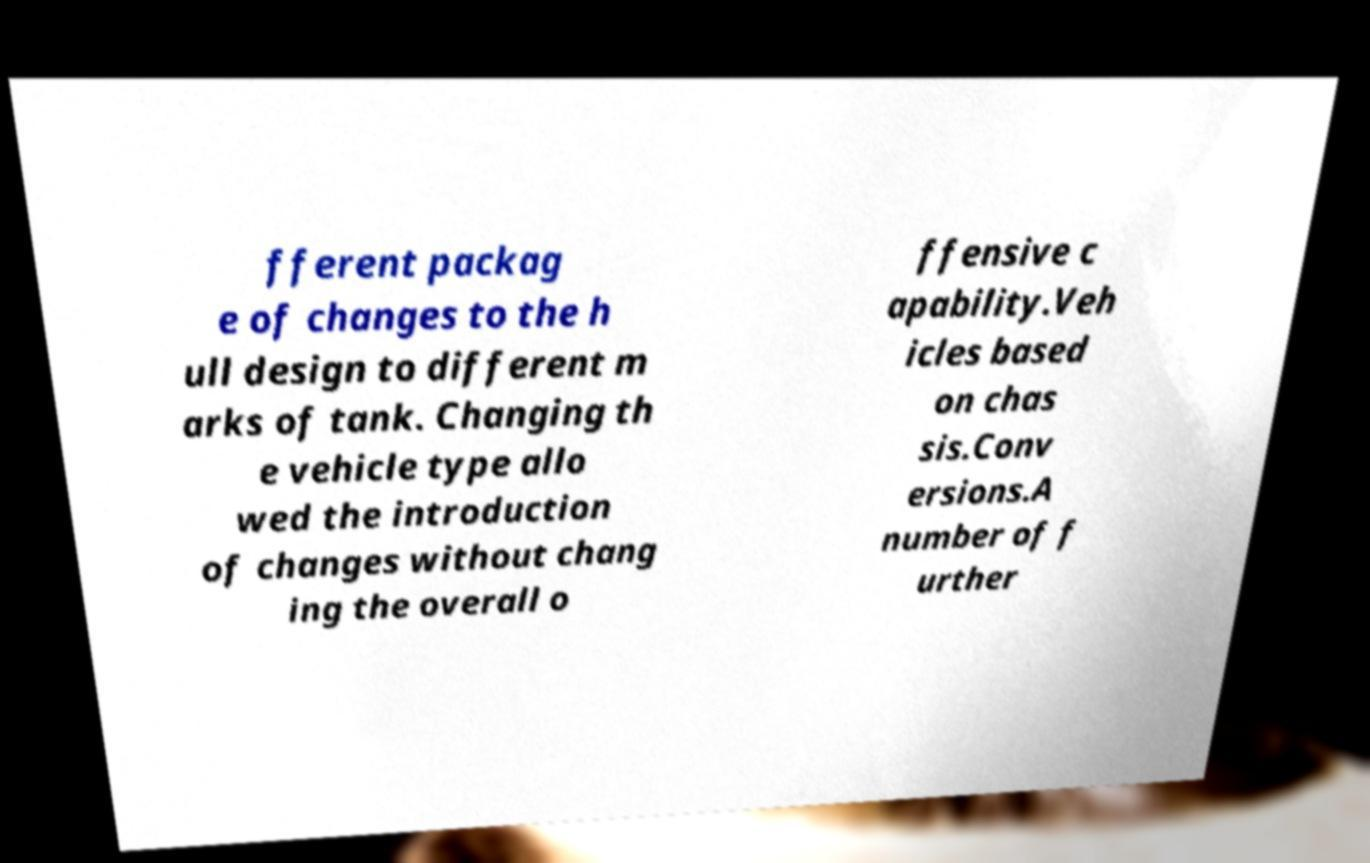What messages or text are displayed in this image? I need them in a readable, typed format. fferent packag e of changes to the h ull design to different m arks of tank. Changing th e vehicle type allo wed the introduction of changes without chang ing the overall o ffensive c apability.Veh icles based on chas sis.Conv ersions.A number of f urther 